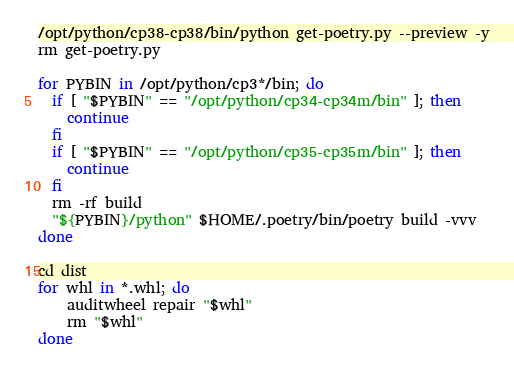<code> <loc_0><loc_0><loc_500><loc_500><_Bash_>/opt/python/cp38-cp38/bin/python get-poetry.py --preview -y
rm get-poetry.py

for PYBIN in /opt/python/cp3*/bin; do
  if [ "$PYBIN" == "/opt/python/cp34-cp34m/bin" ]; then
    continue
  fi
  if [ "$PYBIN" == "/opt/python/cp35-cp35m/bin" ]; then
    continue
  fi
  rm -rf build
  "${PYBIN}/python" $HOME/.poetry/bin/poetry build -vvv
done

cd dist
for whl in *.whl; do
    auditwheel repair "$whl"
    rm "$whl"
done
</code> 